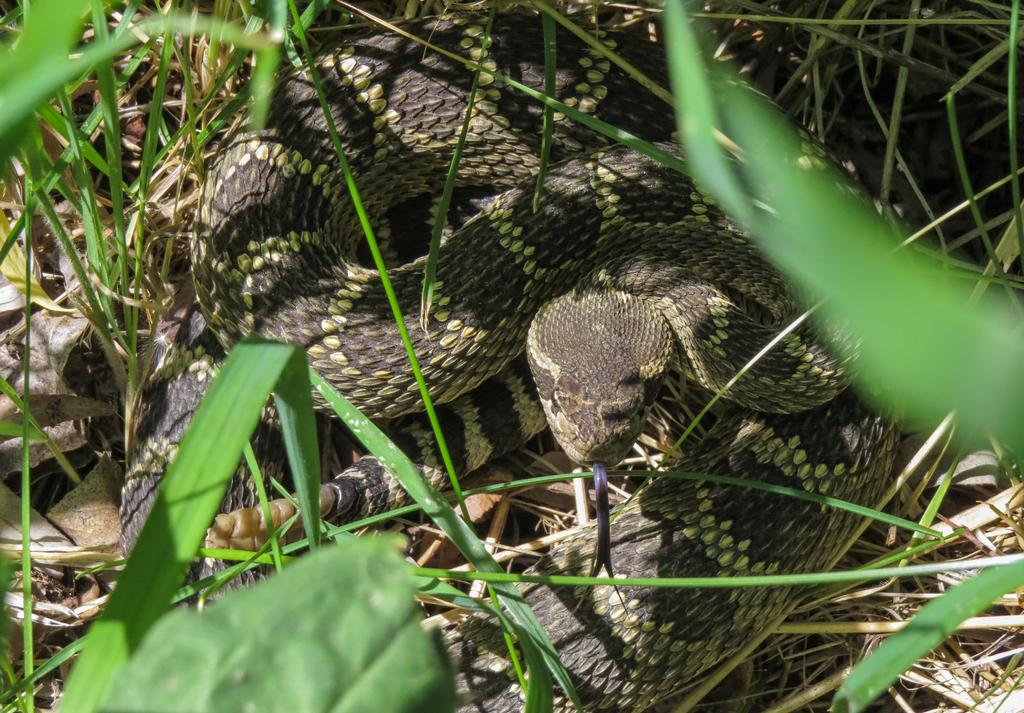What is the main subject in the center of the image? There is a snake in the center of the image. What type of natural environment is visible in the background? There is grass and dry leaves in the background of the image. Where is the train station located in the image? There is no train station present in the image; it features a snake and a natural environment in the background. How many people are in the crowd in the image? There is no crowd present in the image; it features a snake and a natural environment in the background. 